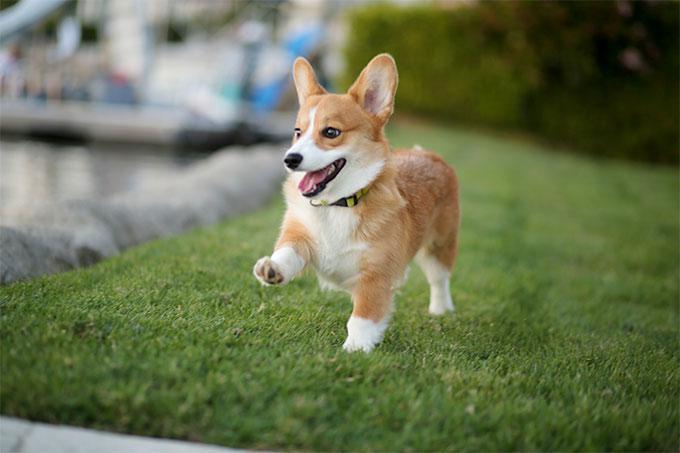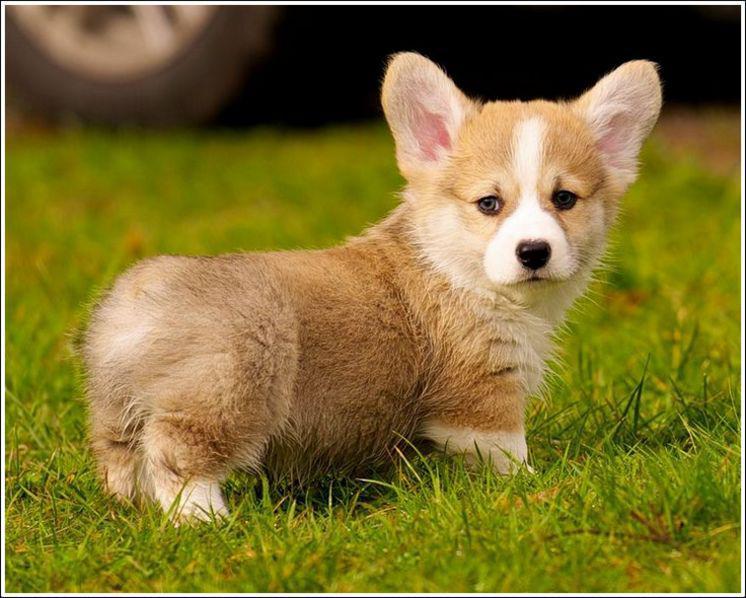The first image is the image on the left, the second image is the image on the right. Examine the images to the left and right. Is the description "At least one dog has its mouth completely closed." accurate? Answer yes or no. Yes. The first image is the image on the left, the second image is the image on the right. Assess this claim about the two images: "Right image shows one short-legged dog standing outdoors.". Correct or not? Answer yes or no. Yes. The first image is the image on the left, the second image is the image on the right. For the images shown, is this caption "There is no more than one dog standing on grass in the left image." true? Answer yes or no. Yes. The first image is the image on the left, the second image is the image on the right. For the images displayed, is the sentence "A dog in one image has a partial black coat and is looking up with its mouth open." factually correct? Answer yes or no. No. The first image is the image on the left, the second image is the image on the right. For the images displayed, is the sentence "In at least one of the images, the corgi is NOT on the grass." factually correct? Answer yes or no. No. 